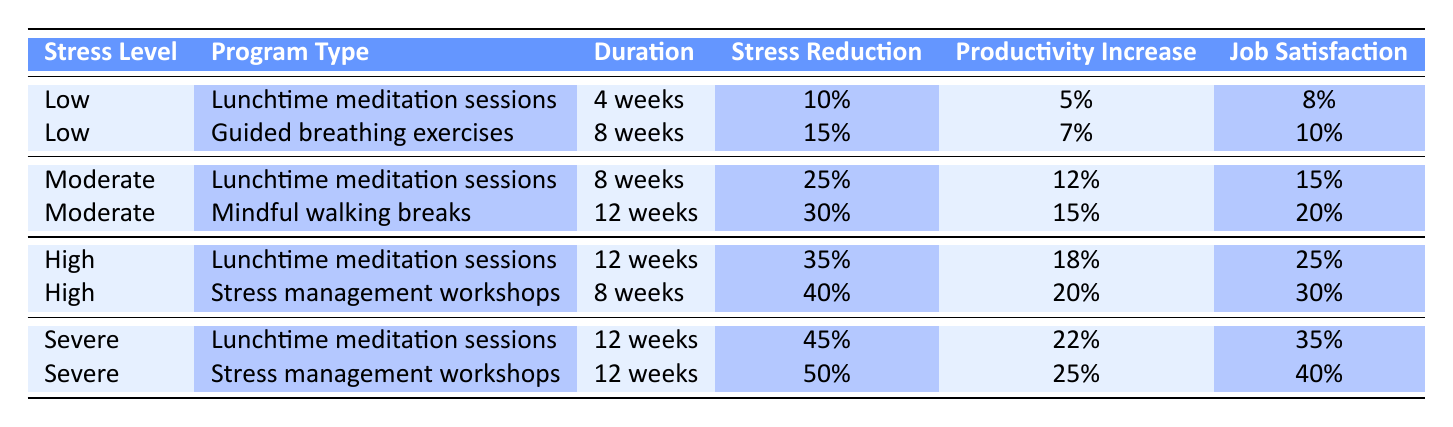What is the highest percentage of stress reduction achieved in the mindfulness programs? The highest percentage of stress reduction noted in the table is 50%, which is linked to the "Stress management workshops" for employees with a "Severe" stress level.
Answer: 50% Which mindfulness program for employees with "Moderate" stress levels offers the greatest improvement in job satisfaction? Among the mindfulness programs for "Moderate" stress levels, "Mindful walking breaks" (12 weeks) shows a job satisfaction improvement of 20%, which is greater than the 15% from "Lunchtime meditation sessions" (8 weeks).
Answer: Mindful walking breaks How many percentage points of productivity increase are observed in "Severe" stress level employees participating in stress management workshops compared to those participating in lunchtime meditation sessions? The productivity increase for "Severe" stress level employees in "Stress management workshops" is 25%, while it is 22% for "Lunchtime meditation sessions." The difference is 25% - 22% = 3 percentage points.
Answer: 3 percentage points Is the stress reduction greater in the "Lunchtime meditation sessions" for "High" stress levels than in the "Guided breathing exercises" for "Low" stress levels? The stress reduction from "Lunchtime meditation sessions" for "High" stress levels is 35%, while for "Guided breathing exercises" for "Low" stress levels it is 15%. Since 35% is greater than 15%, the statement is true.
Answer: Yes What is the average job satisfaction improvement across all mindfulness programs for employees with "Severe" stress levels? There are two entries for "Severe" stress levels: "Lunchtime meditation sessions" (35%) and "Stress management workshops" (40%). To find the average, sum them up (35% + 40%) and divide by 2, which equals 37.5%.
Answer: 37.5% 